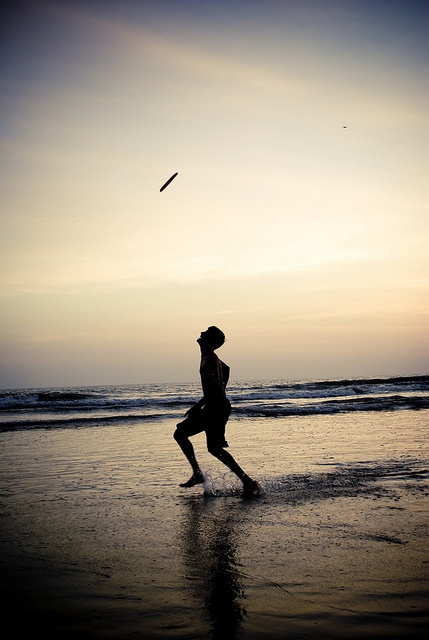Describe the objects in this image and their specific colors. I can see people in black, gray, and darkgray tones and frisbee in black, beige, tan, and gray tones in this image. 